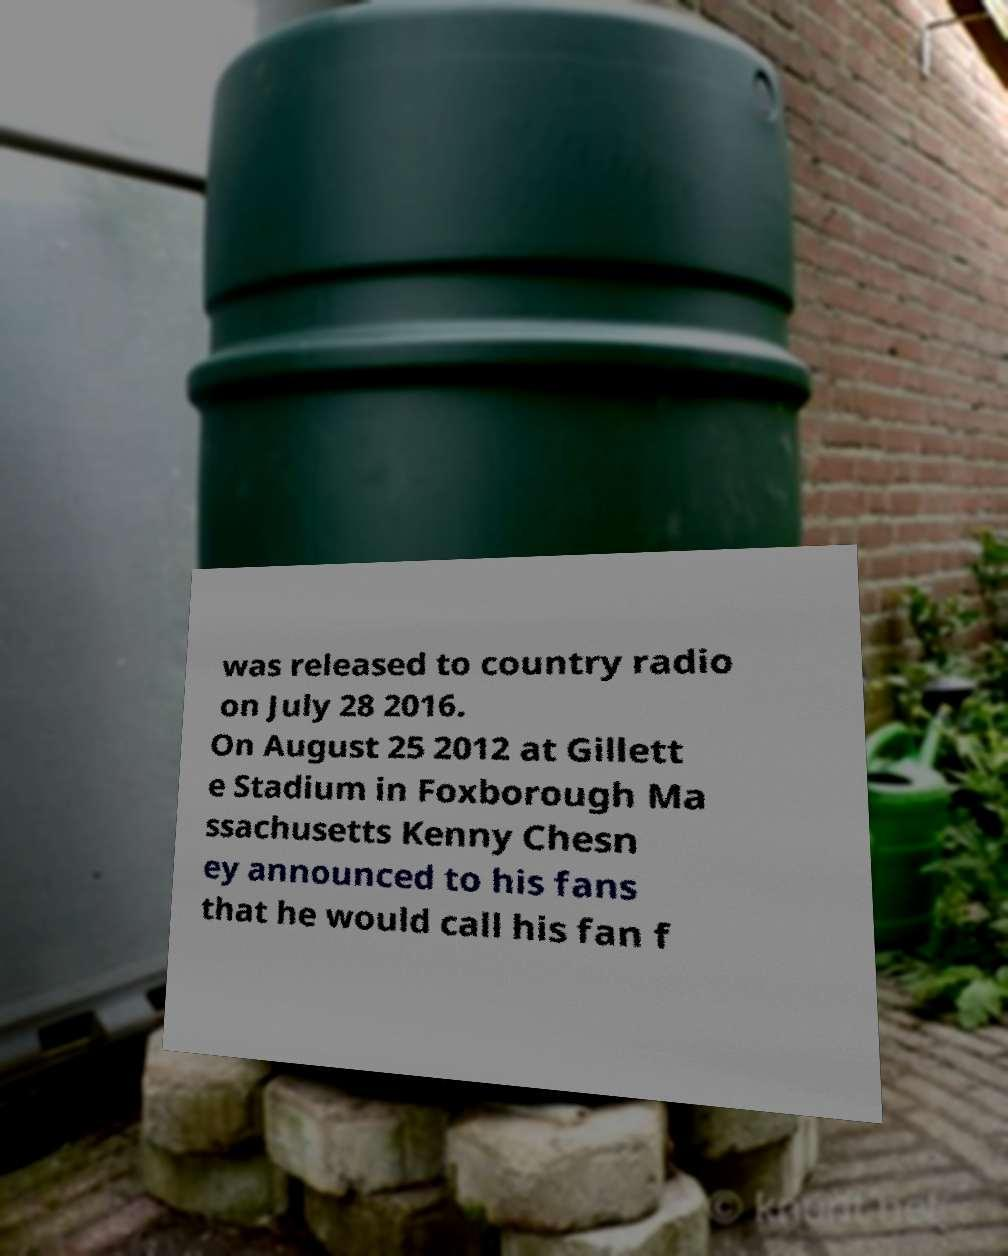What messages or text are displayed in this image? I need them in a readable, typed format. was released to country radio on July 28 2016. On August 25 2012 at Gillett e Stadium in Foxborough Ma ssachusetts Kenny Chesn ey announced to his fans that he would call his fan f 